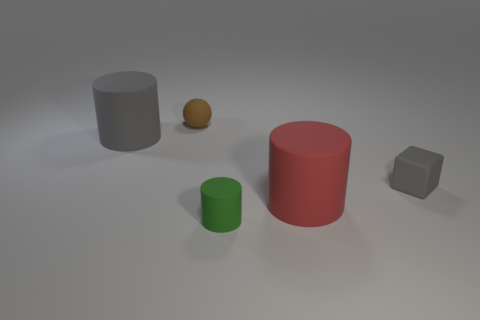How many other objects are there of the same shape as the small brown rubber thing?
Keep it short and to the point. 0. What color is the tiny matte object to the right of the small green matte object?
Offer a terse response. Gray. Do the big gray thing and the brown rubber object have the same shape?
Your answer should be very brief. No. There is a tiny object that is left of the cube and behind the big red thing; what is its color?
Your answer should be compact. Brown. Do the rubber cylinder that is behind the red object and the cylinder that is on the right side of the tiny green cylinder have the same size?
Your answer should be very brief. Yes. How many things are either matte things that are behind the green cylinder or red cylinders?
Offer a terse response. 4. What is the brown thing made of?
Provide a succinct answer. Rubber. Is the size of the brown matte sphere the same as the gray rubber cylinder?
Your answer should be very brief. No. How many cylinders are either brown matte things or big gray objects?
Make the answer very short. 1. There is a large matte thing to the left of the tiny rubber object behind the cube; what is its color?
Your answer should be compact. Gray. 